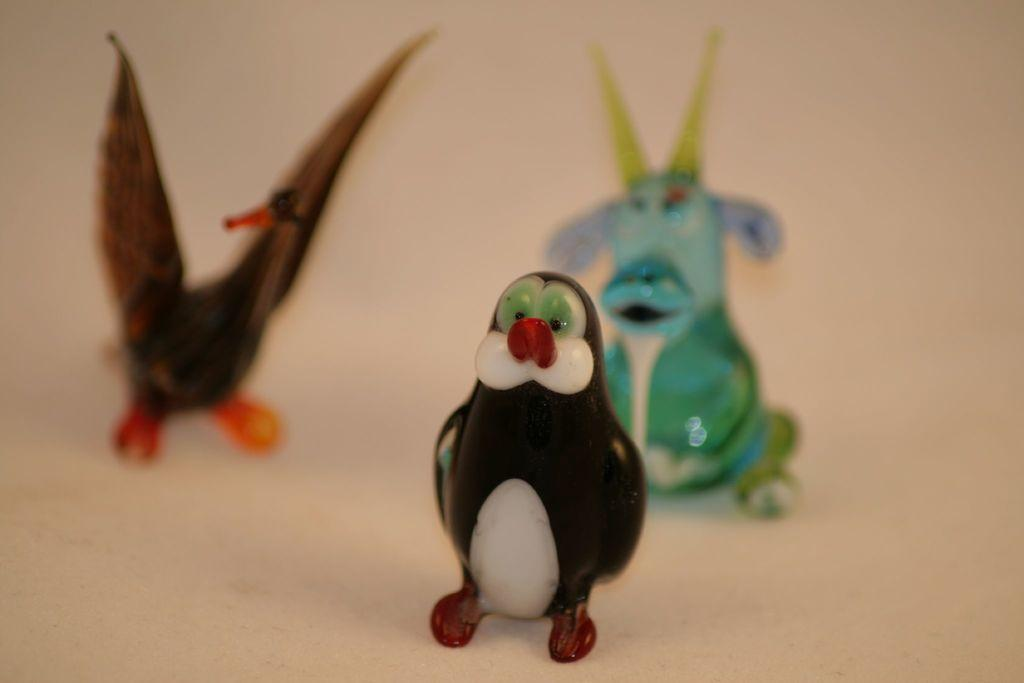What objects can be seen on the surface in the image? There are toys on a surface in the image. What kind of trouble is the school experiencing in the image? There is no school or any indication of trouble in the image; it only features toys on a surface. 